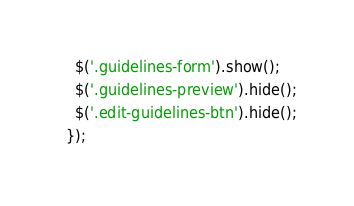<code> <loc_0><loc_0><loc_500><loc_500><_JavaScript_>    $('.guidelines-form').show();
    $('.guidelines-preview').hide();
    $('.edit-guidelines-btn').hide();
  });
</code> 